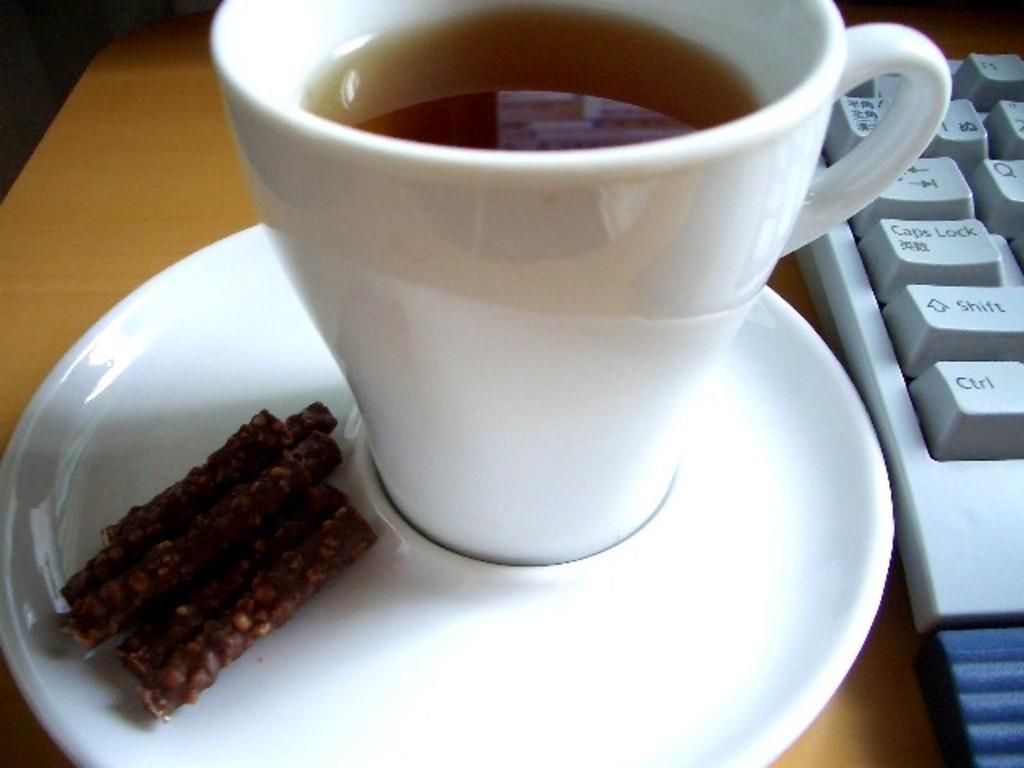Can you describe this image briefly? There is a white cup of drink and food item and a white plate. There is a white keyboard on the right on a wooden surface. 